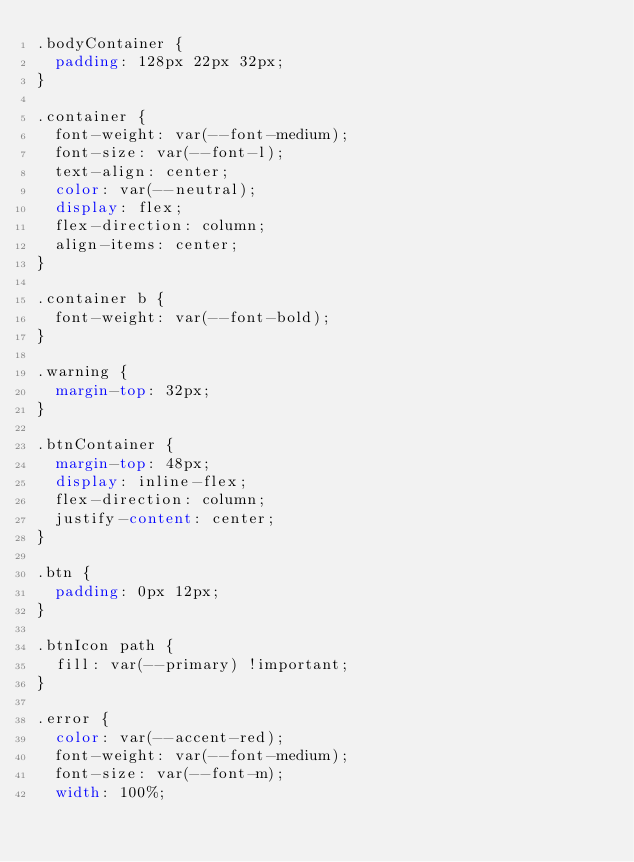Convert code to text. <code><loc_0><loc_0><loc_500><loc_500><_CSS_>.bodyContainer {
  padding: 128px 22px 32px;
}

.container {
  font-weight: var(--font-medium);
  font-size: var(--font-l);
  text-align: center;
  color: var(--neutral);
  display: flex;
  flex-direction: column;
  align-items: center;
}

.container b {
  font-weight: var(--font-bold);
}

.warning {
  margin-top: 32px;
}

.btnContainer {
  margin-top: 48px;
  display: inline-flex;
  flex-direction: column;
  justify-content: center;
}

.btn {
  padding: 0px 12px;
}

.btnIcon path {
  fill: var(--primary) !important;
}

.error {
  color: var(--accent-red);
  font-weight: var(--font-medium);
  font-size: var(--font-m);
  width: 100%;</code> 